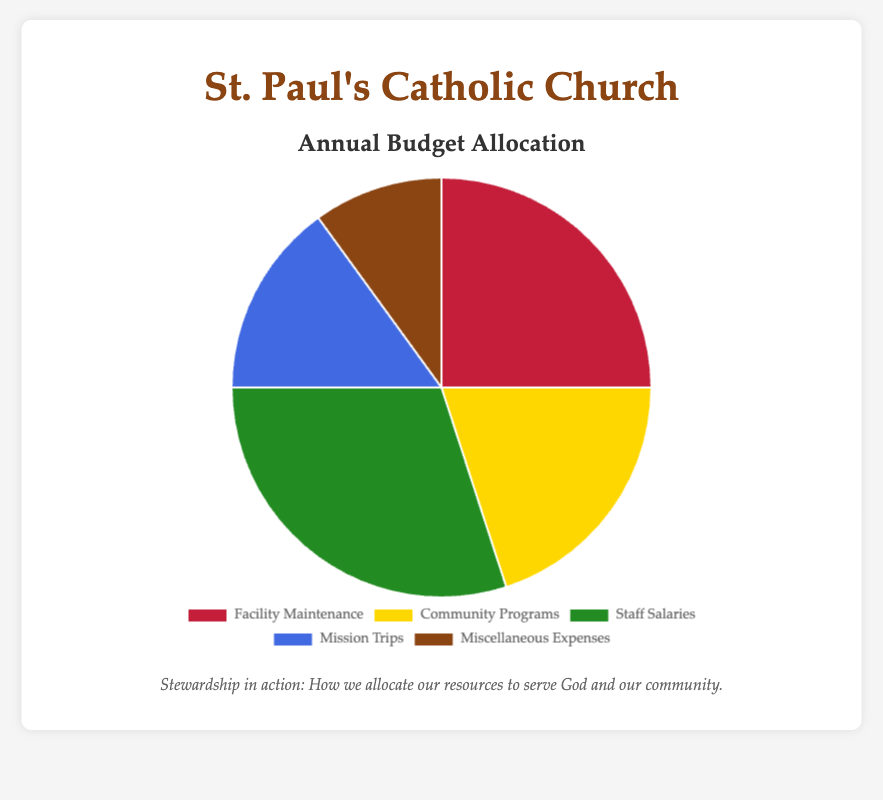What percentage of the budget is allocated to Staff Salaries? The pie chart shows that the segment labeled "Staff Salaries" contains 30%.
Answer: 30% Which category has the smallest allocation in the budget? The pie chart segment labeled "Miscellaneous Expenses" has the smallest percentage of 10%.
Answer: Miscellaneous Expenses How much more budget percentage is allocated to Facility Maintenance compared to Mission Trips? Facility Maintenance is allocated 25%, and Mission Trips are allocated 15%. The difference is 25% - 15% = 10%.
Answer: 10% What is the total percentage allocated to Community Programs and Mission Trips combined? Community Programs have 20%, and Mission Trips have 15%. The combined total is 20% + 15% = 35%.
Answer: 35% Which category has a larger budget allocation: Community Programs or Miscellaneous Expenses? Community Programs have 20%, and Miscellaneous Expenses have 10%. Community Programs have a larger budget allocation.
Answer: Community Programs What visual color is used for the segment of Facility Maintenance? The pie chart shows that the segment for Facility Maintenance is colored red.
Answer: Red Is the percentage allocated to Community Programs greater than the percentage allocated to Mission Trips? Community Programs have 20%, which is greater than the 15% allocated to Mission Trips.
Answer: Yes What is the average percentage allocated per category? The total budget allocation is 100%. There are 5 categories, so the average is 100% / 5 = 20%.
Answer: 20% If Facility Maintenance and Miscellaneous Expenses were combined into one category, what would be the new percentage allocation for this combined category? Facility Maintenance has 25%, Miscellaneous Expenses has 10%. Combined, they would have 25% + 10% = 35%.
Answer: 35% Which two categories together equal the percentage allocated to Staff Salaries? Staff Salaries have 30%. The percentages for Community Programs (20%) and Miscellaneous Expenses (10%) together equal 20% + 10% = 30%.
Answer: Community Programs and Miscellaneous Expenses 